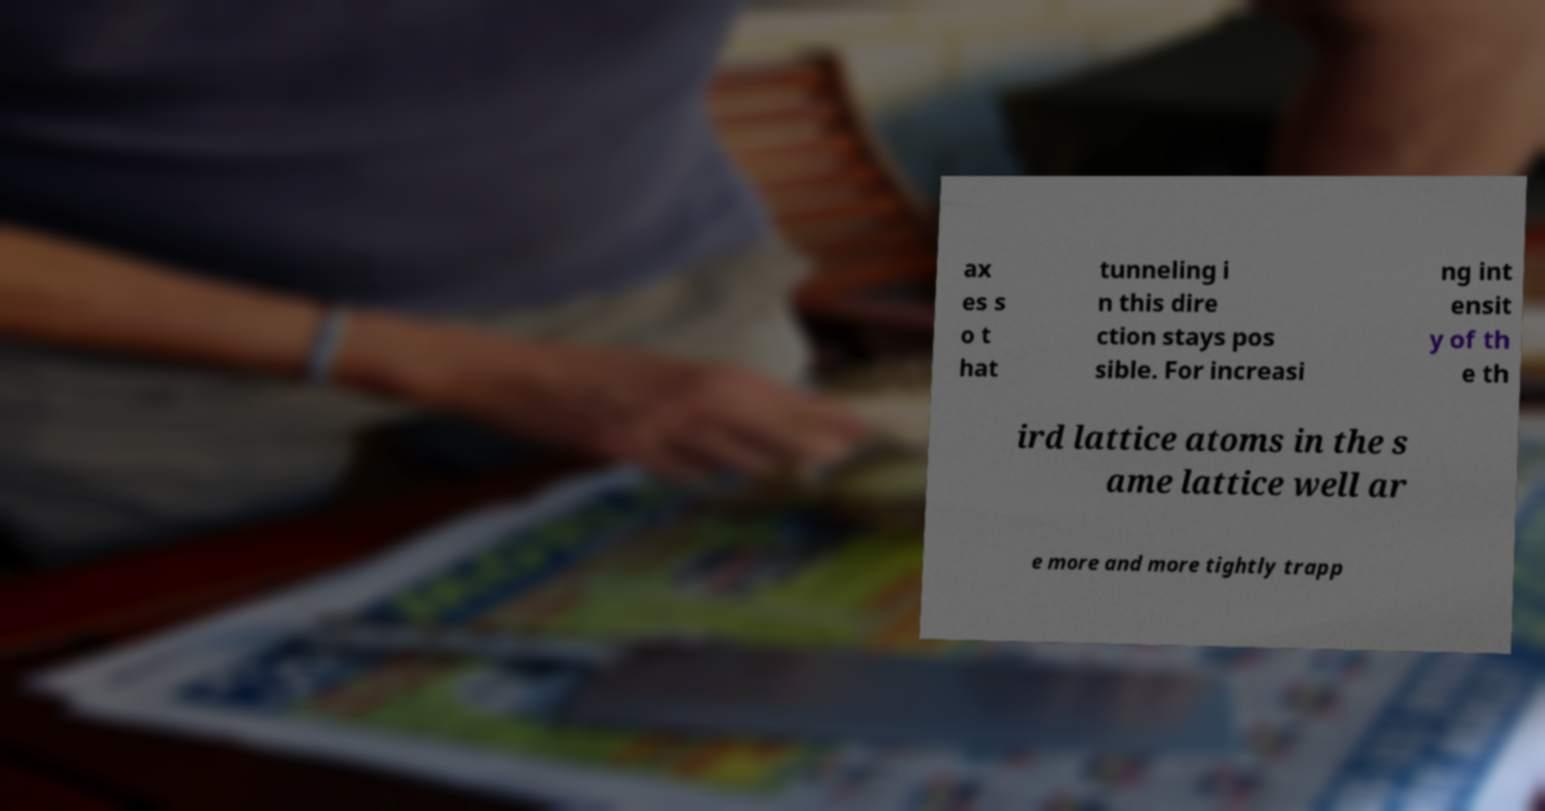There's text embedded in this image that I need extracted. Can you transcribe it verbatim? ax es s o t hat tunneling i n this dire ction stays pos sible. For increasi ng int ensit y of th e th ird lattice atoms in the s ame lattice well ar e more and more tightly trapp 